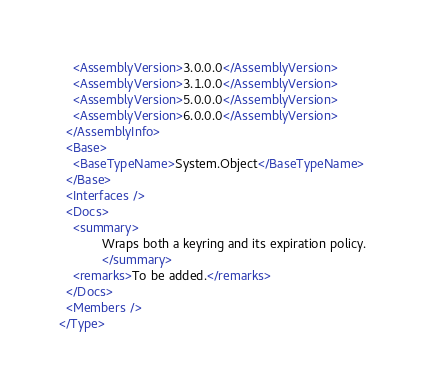<code> <loc_0><loc_0><loc_500><loc_500><_XML_>    <AssemblyVersion>3.0.0.0</AssemblyVersion>
    <AssemblyVersion>3.1.0.0</AssemblyVersion>
    <AssemblyVersion>5.0.0.0</AssemblyVersion>
    <AssemblyVersion>6.0.0.0</AssemblyVersion>
  </AssemblyInfo>
  <Base>
    <BaseTypeName>System.Object</BaseTypeName>
  </Base>
  <Interfaces />
  <Docs>
    <summary>
            Wraps both a keyring and its expiration policy.
            </summary>
    <remarks>To be added.</remarks>
  </Docs>
  <Members />
</Type>
</code> 